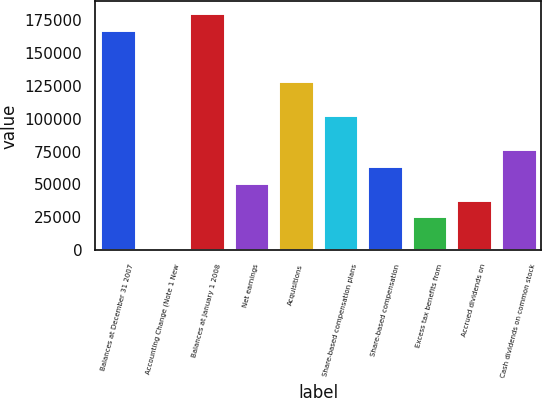<chart> <loc_0><loc_0><loc_500><loc_500><bar_chart><fcel>Balances at December 31 2007<fcel>Accounting Change (Note 1 New<fcel>Balances at January 1 2008<fcel>Net earnings<fcel>Acquisitions<fcel>Share-based compensation plans<fcel>Share-based compensation<fcel>Excess tax benefits from<fcel>Accrued dividends on<fcel>Cash dividends on common stock<nl><fcel>167141<fcel>0.43<fcel>179998<fcel>51428.3<fcel>128570<fcel>102856<fcel>64285.2<fcel>25714.3<fcel>38571.3<fcel>77142.2<nl></chart> 